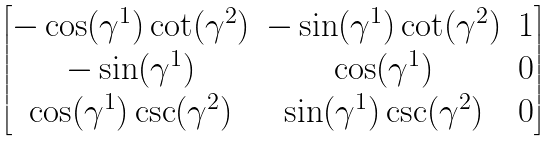<formula> <loc_0><loc_0><loc_500><loc_500>\begin{bmatrix} - \cos ( \gamma ^ { 1 } ) \cot ( \gamma ^ { 2 } ) & - \sin ( \gamma ^ { 1 } ) \cot ( \gamma ^ { 2 } ) & 1 \\ - \sin ( \gamma ^ { 1 } ) & \cos ( \gamma ^ { 1 } ) & 0 \\ \cos ( \gamma ^ { 1 } ) \csc ( \gamma ^ { 2 } ) & \sin ( \gamma ^ { 1 } ) \csc ( \gamma ^ { 2 } ) & 0 \end{bmatrix}</formula> 